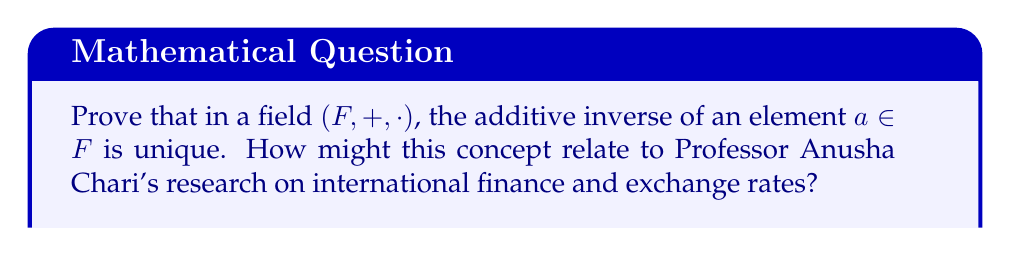Help me with this question. Let's prove the uniqueness of the additive inverse in a field step by step:

1) Let $a \in F$ be an arbitrary element of the field.

2) Suppose $b$ and $c$ are both additive inverses of $a$. We need to show that $b = c$.

3) By definition of additive inverse:
   $$a + b = 0$$ and $$a + c = 0$$
   where $0$ is the additive identity of the field.

4) Now, let's consider $b$:
   $$b = b + 0$$ (additive identity property)
   $$= b + (a + c)$$ (substituting $a + c = 0$ from step 3)
   $$= (b + a) + c$$ (associativity of addition in a field)
   $$= (a + b) + c$$ (commutativity of addition in a field)
   $$= 0 + c$$ (substituting $a + b = 0$ from step 3)
   $$= c$$ (additive identity property)

5) Therefore, $b = c$, proving that the additive inverse is unique.

This concept relates to Professor Anusha Chari's research on international finance and exchange rates in several ways:

1) In foreign exchange markets, each currency has a unique inverse exchange rate with respect to another currency.
2) The uniqueness of inverses ensures consistency in financial calculations and models used in international economics.
3) Understanding field properties is crucial for developing mathematical models in economics, which are often used in Professor Chari's research on global financial markets and monetary policy.
Answer: The additive inverse is unique because if $b$ and $c$ are both inverses of $a$, then $b = b + 0 = b + (a + c) = (b + a) + c = 0 + c = c$. 